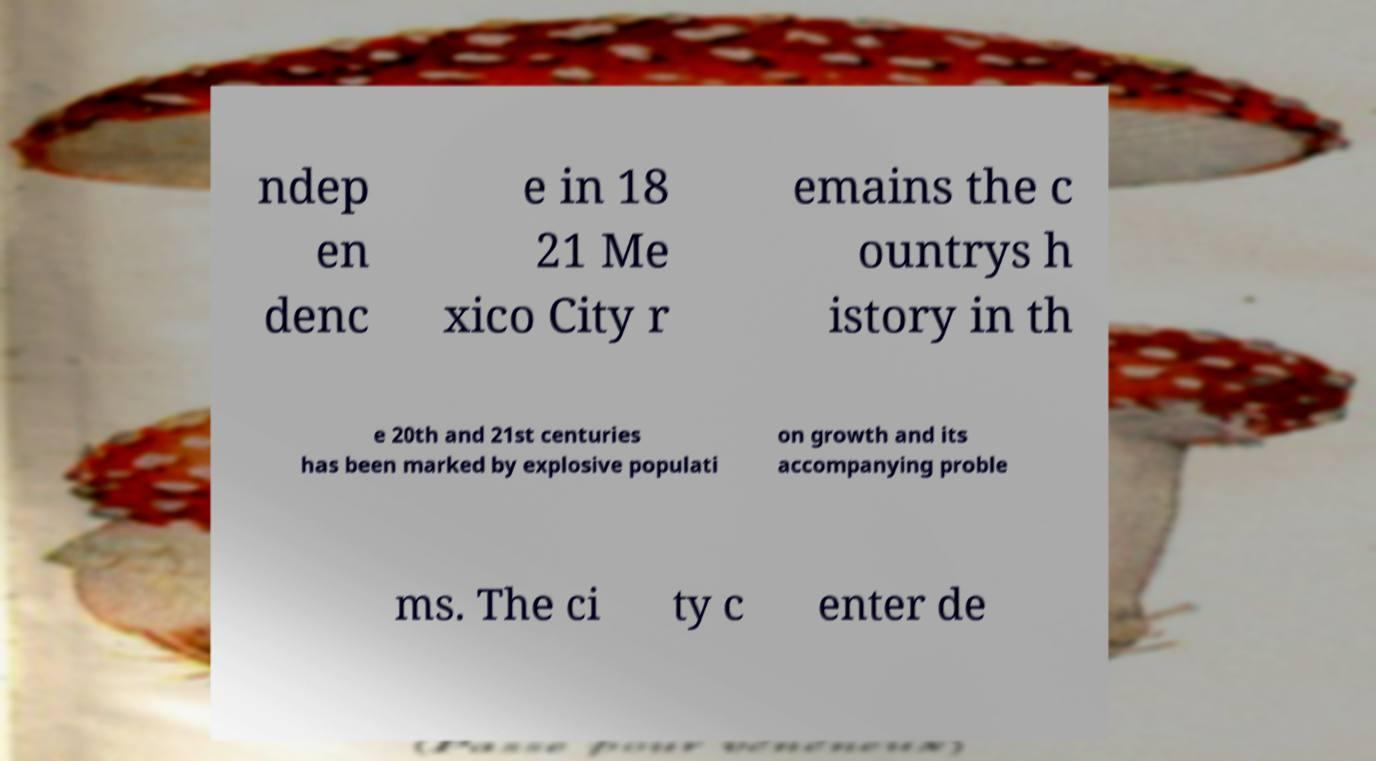Please identify and transcribe the text found in this image. ndep en denc e in 18 21 Me xico City r emains the c ountrys h istory in th e 20th and 21st centuries has been marked by explosive populati on growth and its accompanying proble ms. The ci ty c enter de 